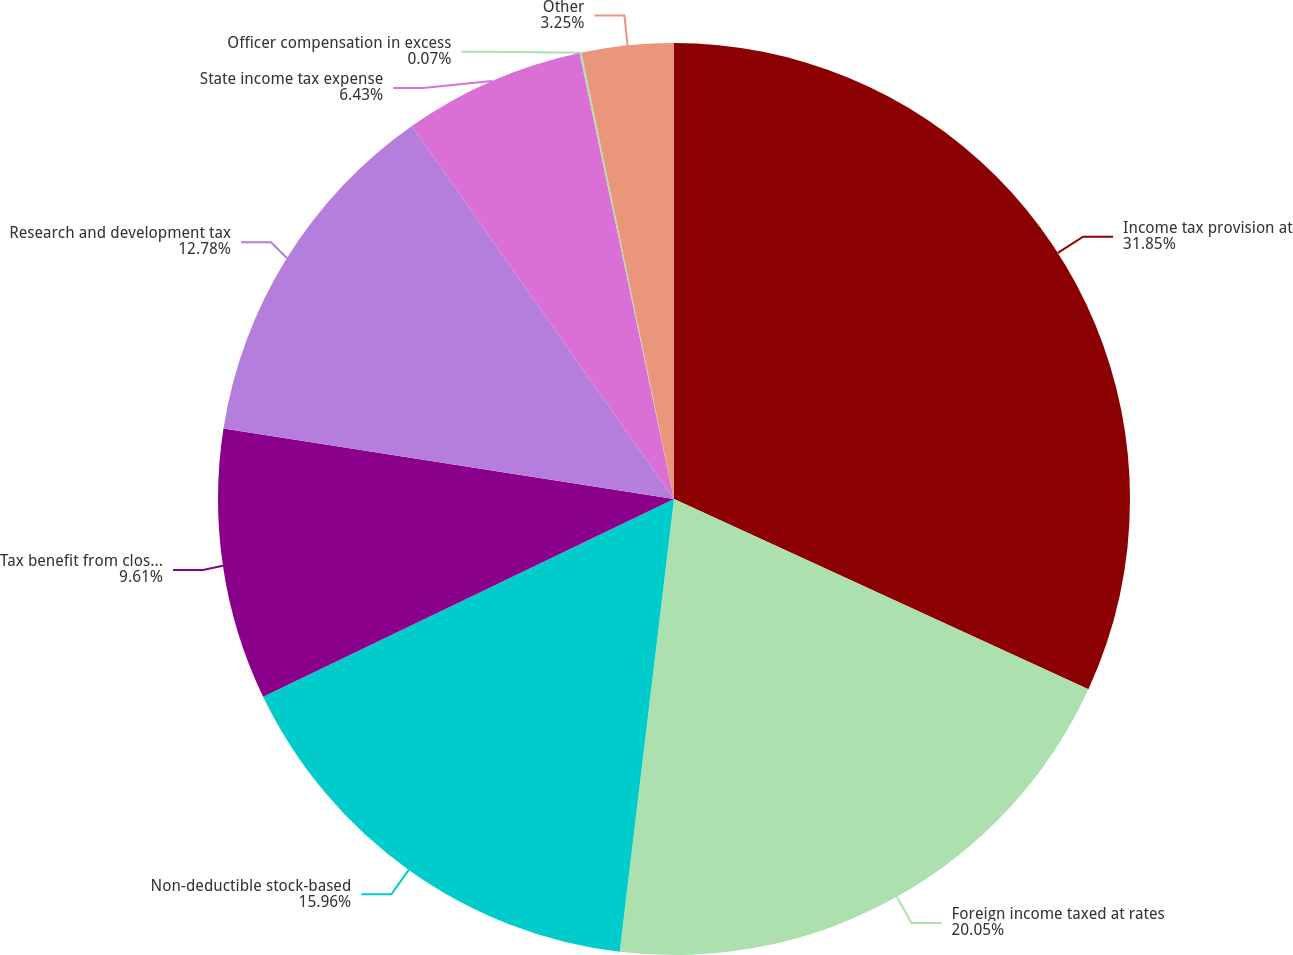Convert chart. <chart><loc_0><loc_0><loc_500><loc_500><pie_chart><fcel>Income tax provision at<fcel>Foreign income taxed at rates<fcel>Non-deductible stock-based<fcel>Tax benefit from closure of<fcel>Research and development tax<fcel>State income tax expense<fcel>Officer compensation in excess<fcel>Other<nl><fcel>31.85%<fcel>20.05%<fcel>15.96%<fcel>9.61%<fcel>12.78%<fcel>6.43%<fcel>0.07%<fcel>3.25%<nl></chart> 